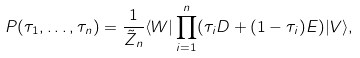Convert formula to latex. <formula><loc_0><loc_0><loc_500><loc_500>P ( \tau _ { 1 } , \dots , \tau _ { n } ) = \frac { 1 } { \tilde { Z } _ { n } } \langle W | \prod _ { i = 1 } ^ { n } ( \tau _ { i } D + ( 1 - \tau _ { i } ) E ) | V \rangle ,</formula> 